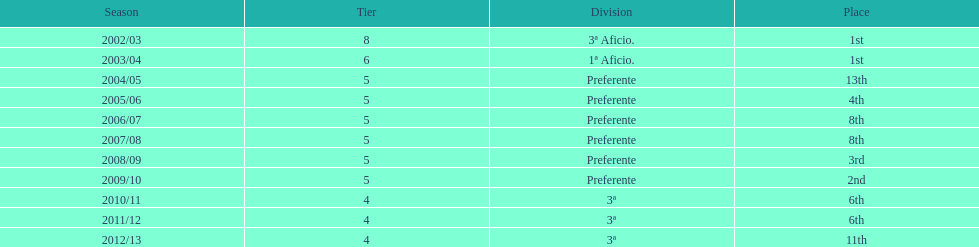In which seasons did tier four take place? 2010/11, 2011/12, 2012/13. Among these seasons, which finished in 6th position? 2010/11, 2011/12. Which of the remaining occurred last? 2011/12. 